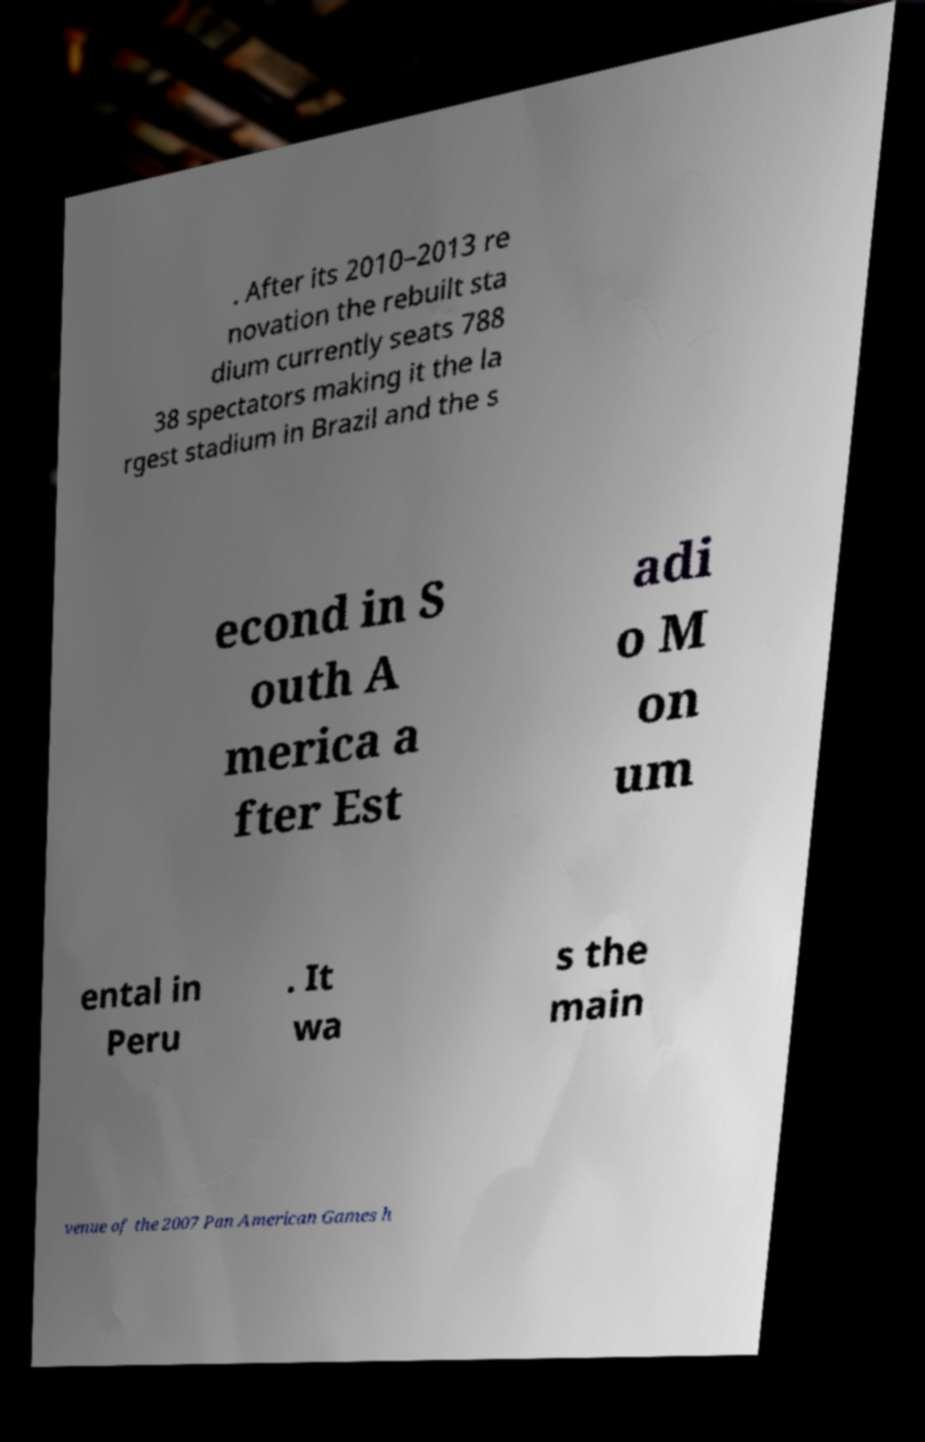Could you extract and type out the text from this image? . After its 2010–2013 re novation the rebuilt sta dium currently seats 788 38 spectators making it the la rgest stadium in Brazil and the s econd in S outh A merica a fter Est adi o M on um ental in Peru . It wa s the main venue of the 2007 Pan American Games h 